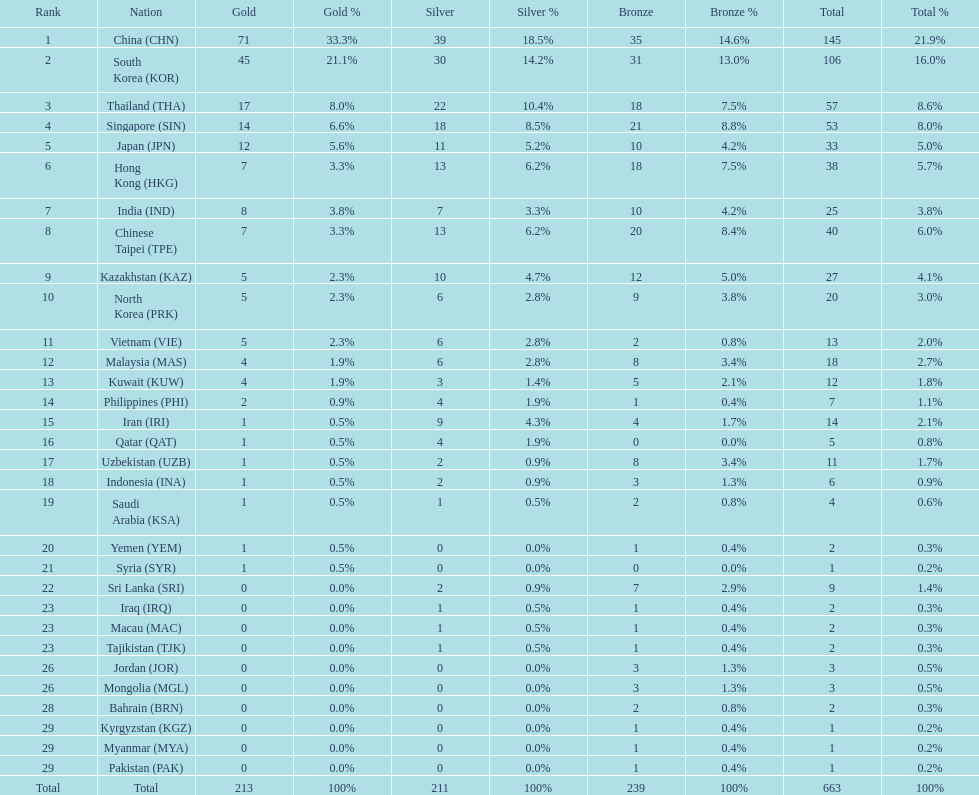What is the total number of medals that india won in the asian youth games? 25. 